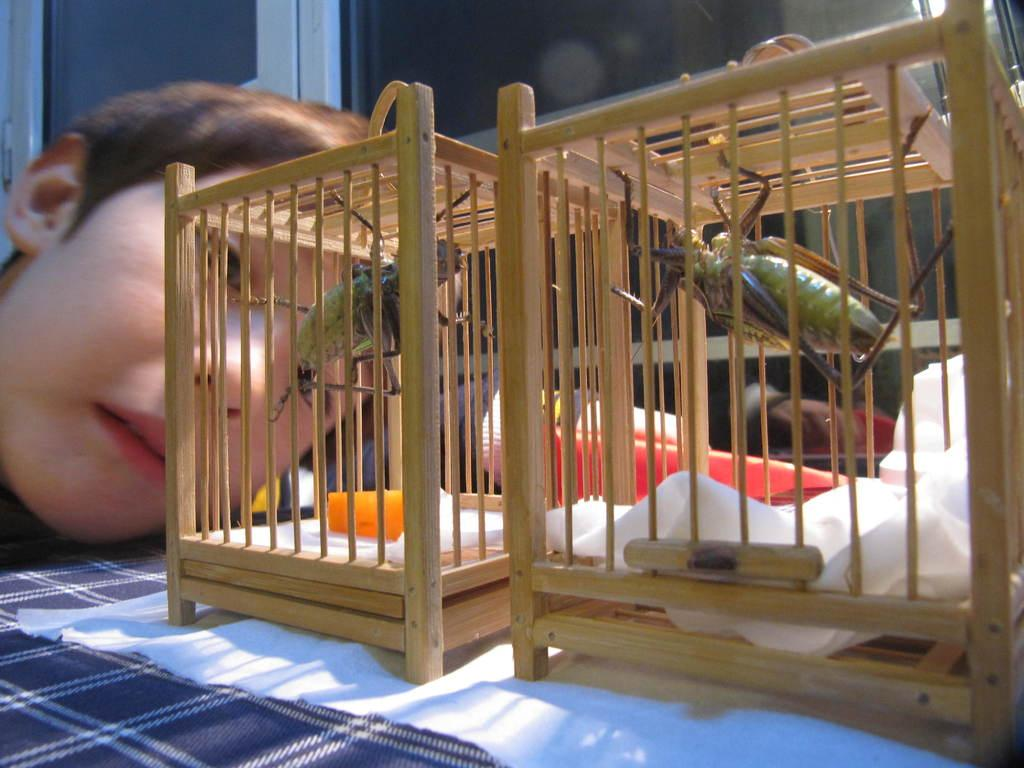What type of creatures are present in the image? There are insects in the image. How are the insects contained in the image? The insects are in mini wooden cages. What is the object on which the mini wooden cages are placed? The mini wooden cages are on an object, but the specific object is not mentioned in the facts. Can you describe the presence of a person in the image? There is a person in the background of the image. What type of snake can be seen slithering on the shelf in the image? There is no snake or shelf present in the image; it features insects in mini wooden cages. 